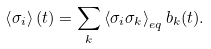<formula> <loc_0><loc_0><loc_500><loc_500>\left < \sigma _ { i } \right > ( t ) = \sum _ { k } \left < \sigma _ { i } \sigma _ { k } \right > _ { e q } b _ { k } ( t ) .</formula> 